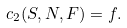Convert formula to latex. <formula><loc_0><loc_0><loc_500><loc_500>c _ { 2 } ( S , N , F ) = f .</formula> 